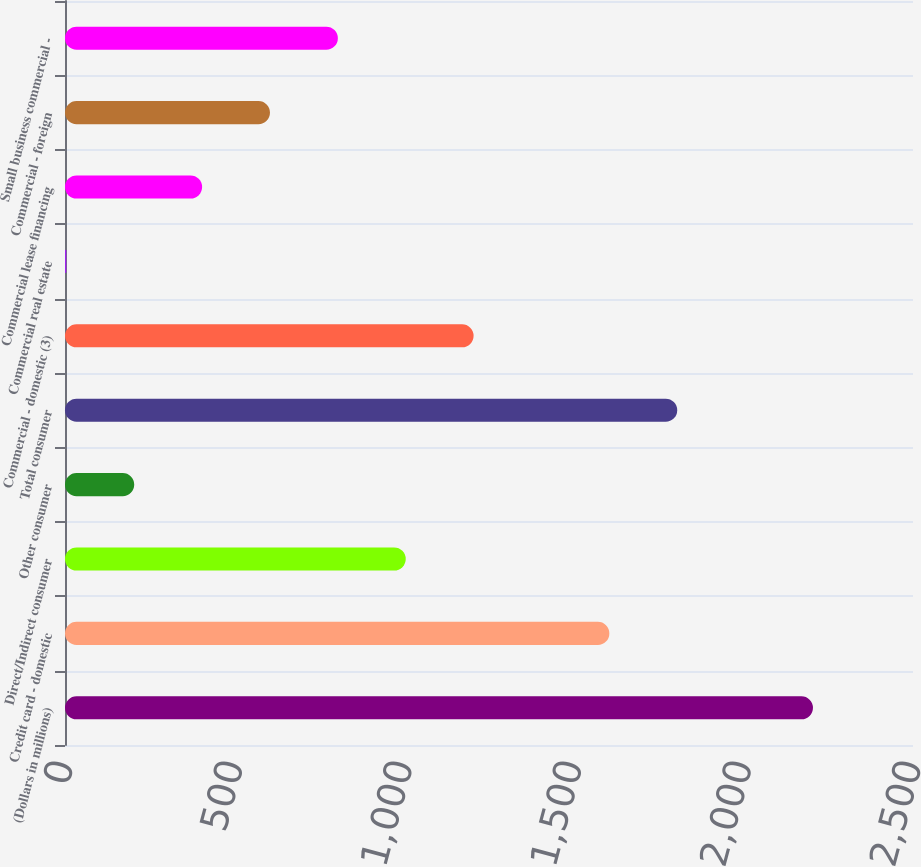<chart> <loc_0><loc_0><loc_500><loc_500><bar_chart><fcel>(Dollars in millions)<fcel>Credit card - domestic<fcel>Direct/Indirect consumer<fcel>Other consumer<fcel>Total consumer<fcel>Commercial - domestic (3)<fcel>Commercial real estate<fcel>Commercial lease financing<fcel>Commercial - foreign<fcel>Small business commercial -<nl><fcel>2205.1<fcel>1604.8<fcel>1004.5<fcel>204.1<fcel>1804.9<fcel>1204.6<fcel>4<fcel>404.2<fcel>604.3<fcel>804.4<nl></chart> 